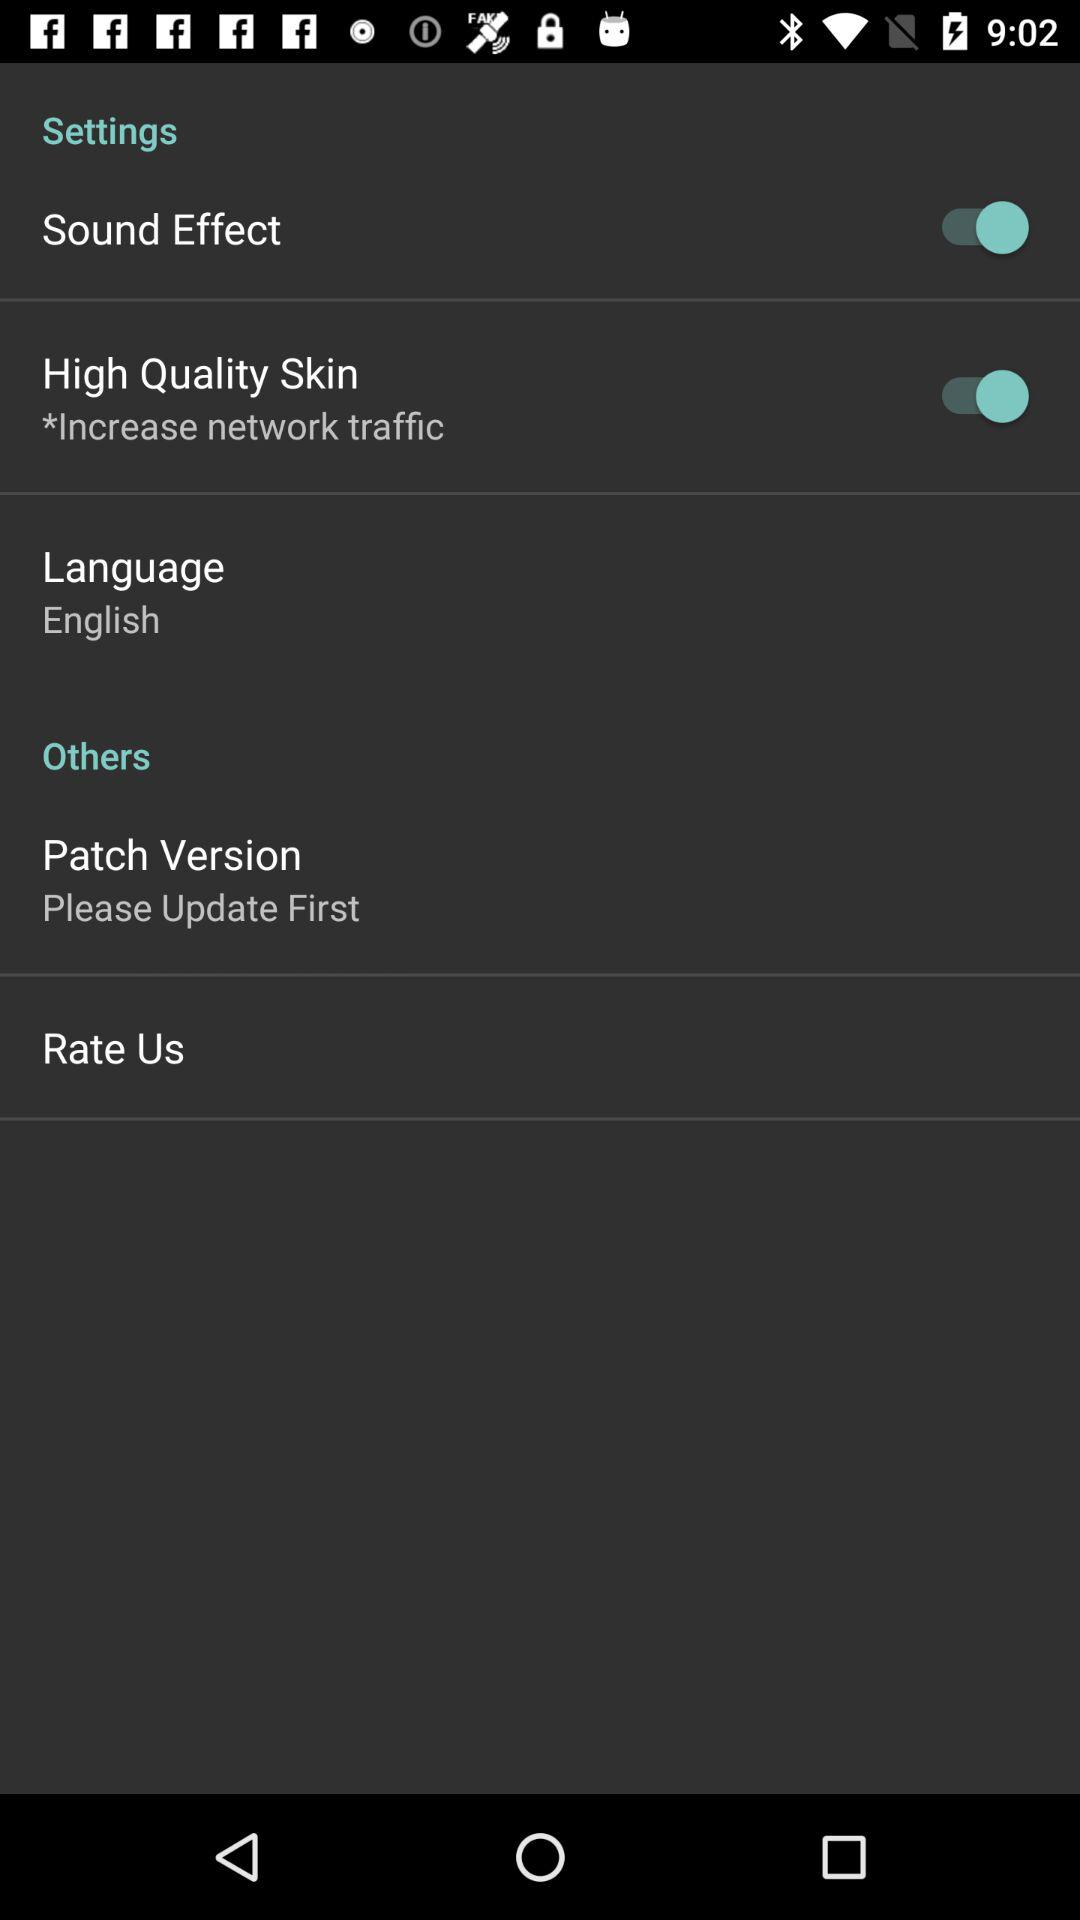How many items have a switch?
Answer the question using a single word or phrase. 2 